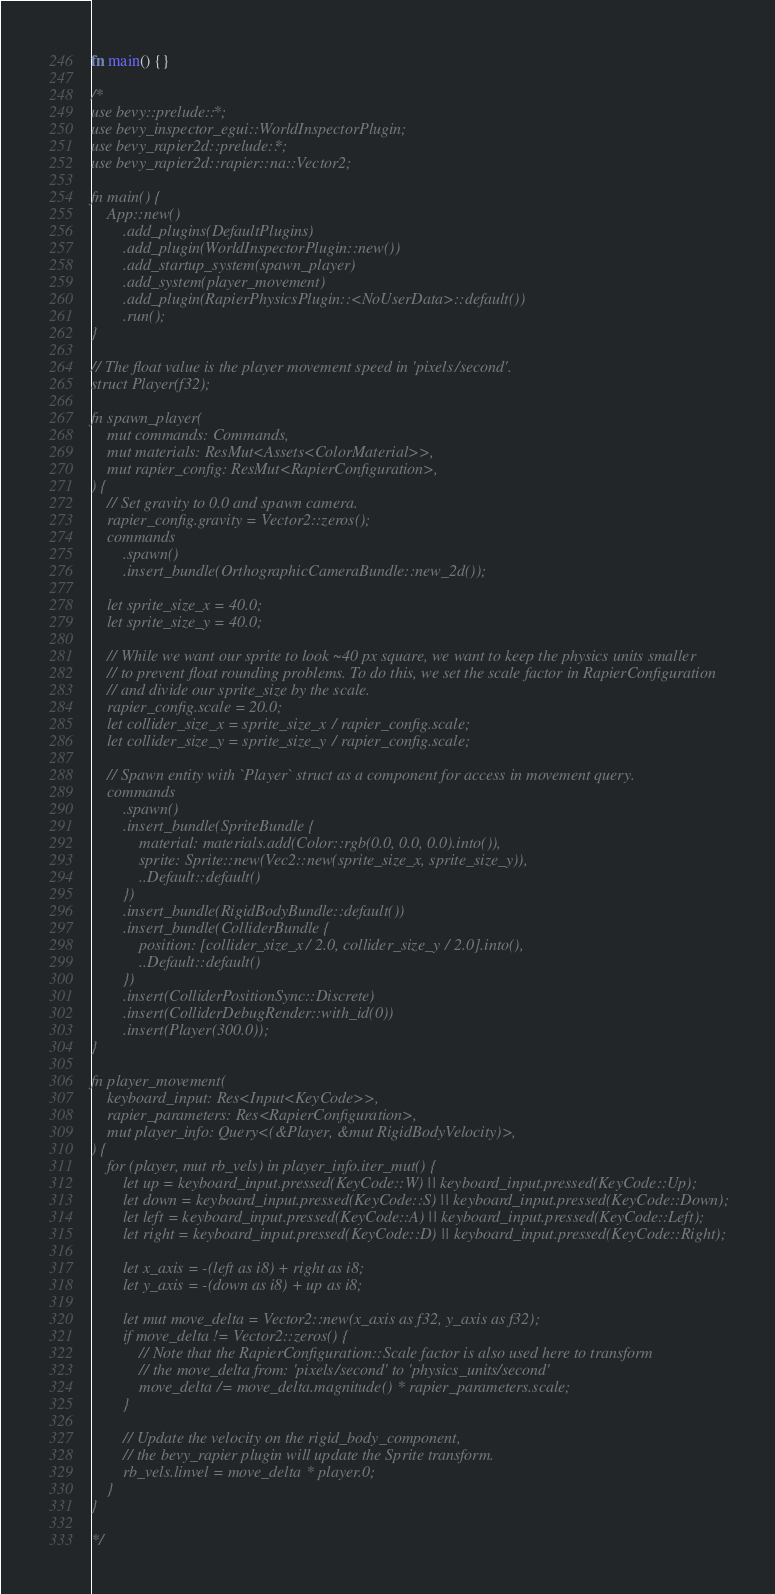<code> <loc_0><loc_0><loc_500><loc_500><_Rust_>fn main() {}

/*
use bevy::prelude::*;
use bevy_inspector_egui::WorldInspectorPlugin;
use bevy_rapier2d::prelude::*;
use bevy_rapier2d::rapier::na::Vector2;

fn main() {
    App::new()
        .add_plugins(DefaultPlugins)
        .add_plugin(WorldInspectorPlugin::new())
        .add_startup_system(spawn_player)
        .add_system(player_movement)
        .add_plugin(RapierPhysicsPlugin::<NoUserData>::default())
        .run();
}

// The float value is the player movement speed in 'pixels/second'.
struct Player(f32);

fn spawn_player(
    mut commands: Commands,
    mut materials: ResMut<Assets<ColorMaterial>>,
    mut rapier_config: ResMut<RapierConfiguration>,
) {
    // Set gravity to 0.0 and spawn camera.
    rapier_config.gravity = Vector2::zeros();
    commands
        .spawn()
        .insert_bundle(OrthographicCameraBundle::new_2d());

    let sprite_size_x = 40.0;
    let sprite_size_y = 40.0;

    // While we want our sprite to look ~40 px square, we want to keep the physics units smaller
    // to prevent float rounding problems. To do this, we set the scale factor in RapierConfiguration
    // and divide our sprite_size by the scale.
    rapier_config.scale = 20.0;
    let collider_size_x = sprite_size_x / rapier_config.scale;
    let collider_size_y = sprite_size_y / rapier_config.scale;

    // Spawn entity with `Player` struct as a component for access in movement query.
    commands
        .spawn()
        .insert_bundle(SpriteBundle {
            material: materials.add(Color::rgb(0.0, 0.0, 0.0).into()),
            sprite: Sprite::new(Vec2::new(sprite_size_x, sprite_size_y)),
            ..Default::default()
        })
        .insert_bundle(RigidBodyBundle::default())
        .insert_bundle(ColliderBundle {
            position: [collider_size_x / 2.0, collider_size_y / 2.0].into(),
            ..Default::default()
        })
        .insert(ColliderPositionSync::Discrete)
        .insert(ColliderDebugRender::with_id(0))
        .insert(Player(300.0));
}

fn player_movement(
    keyboard_input: Res<Input<KeyCode>>,
    rapier_parameters: Res<RapierConfiguration>,
    mut player_info: Query<(&Player, &mut RigidBodyVelocity)>,
) {
    for (player, mut rb_vels) in player_info.iter_mut() {
        let up = keyboard_input.pressed(KeyCode::W) || keyboard_input.pressed(KeyCode::Up);
        let down = keyboard_input.pressed(KeyCode::S) || keyboard_input.pressed(KeyCode::Down);
        let left = keyboard_input.pressed(KeyCode::A) || keyboard_input.pressed(KeyCode::Left);
        let right = keyboard_input.pressed(KeyCode::D) || keyboard_input.pressed(KeyCode::Right);

        let x_axis = -(left as i8) + right as i8;
        let y_axis = -(down as i8) + up as i8;

        let mut move_delta = Vector2::new(x_axis as f32, y_axis as f32);
        if move_delta != Vector2::zeros() {
            // Note that the RapierConfiguration::Scale factor is also used here to transform
            // the move_delta from: 'pixels/second' to 'physics_units/second'
            move_delta /= move_delta.magnitude() * rapier_parameters.scale;
        }

        // Update the velocity on the rigid_body_component,
        // the bevy_rapier plugin will update the Sprite transform.
        rb_vels.linvel = move_delta * player.0;
    }
}

*/
</code> 